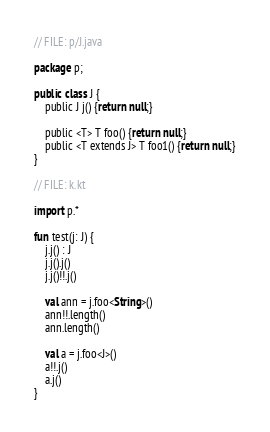<code> <loc_0><loc_0><loc_500><loc_500><_Kotlin_>// FILE: p/J.java

package p;

public class J {
    public J j() {return null;}

    public <T> T foo() {return null;}
    public <T extends J> T foo1() {return null;}
}

// FILE: k.kt

import p.*

fun test(j: J) {
    j.j() : J
    j.j().j()
    j.j()!!.j()

    val ann = j.foo<String>()
    ann!!.length()
    ann.length()

    val a = j.foo<J>()
    a!!.j()
    a.j()
}</code> 